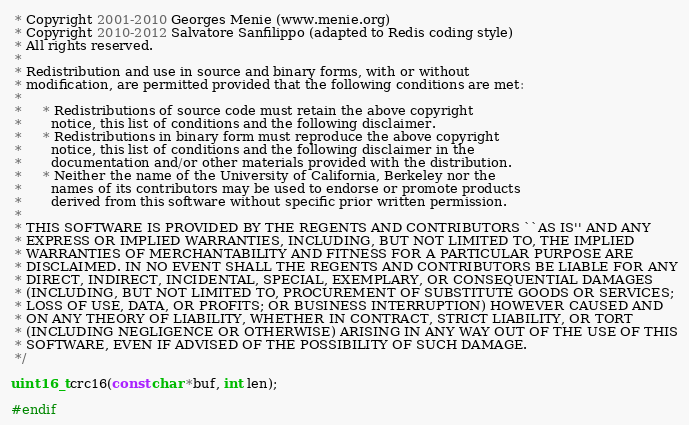<code> <loc_0><loc_0><loc_500><loc_500><_C_> * Copyright 2001-2010 Georges Menie (www.menie.org)
 * Copyright 2010-2012 Salvatore Sanfilippo (adapted to Redis coding style)
 * All rights reserved.
 *
 * Redistribution and use in source and binary forms, with or without
 * modification, are permitted provided that the following conditions are met:
 *
 *     * Redistributions of source code must retain the above copyright
 *       notice, this list of conditions and the following disclaimer.
 *     * Redistributions in binary form must reproduce the above copyright
 *       notice, this list of conditions and the following disclaimer in the
 *       documentation and/or other materials provided with the distribution.
 *     * Neither the name of the University of California, Berkeley nor the
 *       names of its contributors may be used to endorse or promote products
 *       derived from this software without specific prior written permission.
 *
 * THIS SOFTWARE IS PROVIDED BY THE REGENTS AND CONTRIBUTORS ``AS IS'' AND ANY
 * EXPRESS OR IMPLIED WARRANTIES, INCLUDING, BUT NOT LIMITED TO, THE IMPLIED
 * WARRANTIES OF MERCHANTABILITY AND FITNESS FOR A PARTICULAR PURPOSE ARE
 * DISCLAIMED. IN NO EVENT SHALL THE REGENTS AND CONTRIBUTORS BE LIABLE FOR ANY
 * DIRECT, INDIRECT, INCIDENTAL, SPECIAL, EXEMPLARY, OR CONSEQUENTIAL DAMAGES
 * (INCLUDING, BUT NOT LIMITED TO, PROCUREMENT OF SUBSTITUTE GOODS OR SERVICES;
 * LOSS OF USE, DATA, OR PROFITS; OR BUSINESS INTERRUPTION) HOWEVER CAUSED AND
 * ON ANY THEORY OF LIABILITY, WHETHER IN CONTRACT, STRICT LIABILITY, OR TORT
 * (INCLUDING NEGLIGENCE OR OTHERWISE) ARISING IN ANY WAY OUT OF THE USE OF THIS
 * SOFTWARE, EVEN IF ADVISED OF THE POSSIBILITY OF SUCH DAMAGE.
 */

uint16_t crc16(const char *buf, int len);

#endif
</code> 